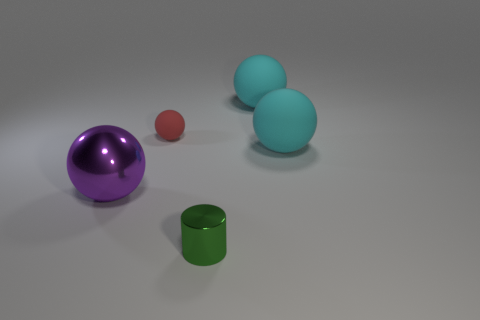Are there any other things of the same color as the small metallic cylinder? Yes, there are two spheres in the image that share the same teal color as the small metallic cylinder. 